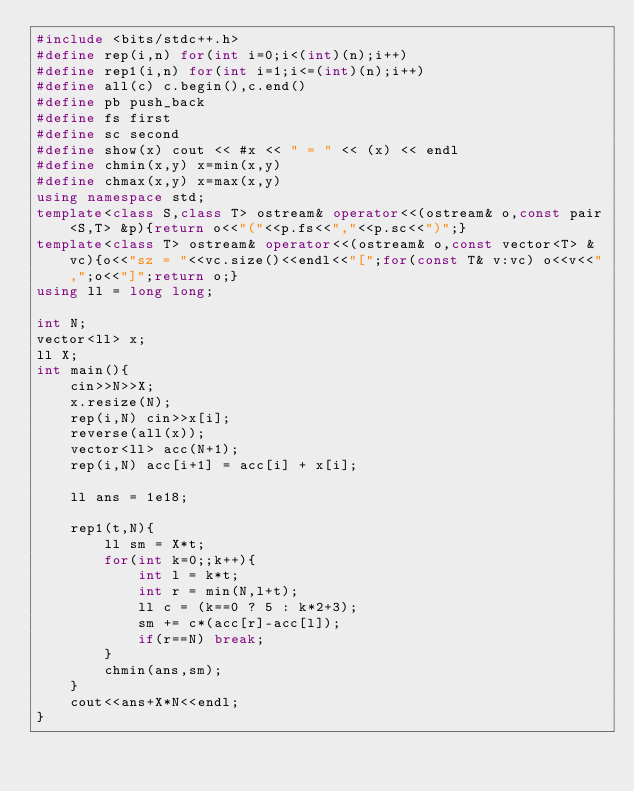<code> <loc_0><loc_0><loc_500><loc_500><_C++_>#include <bits/stdc++.h>
#define rep(i,n) for(int i=0;i<(int)(n);i++)
#define rep1(i,n) for(int i=1;i<=(int)(n);i++)
#define all(c) c.begin(),c.end()
#define pb push_back
#define fs first
#define sc second
#define show(x) cout << #x << " = " << (x) << endl
#define chmin(x,y) x=min(x,y)
#define chmax(x,y) x=max(x,y)
using namespace std;
template<class S,class T> ostream& operator<<(ostream& o,const pair<S,T> &p){return o<<"("<<p.fs<<","<<p.sc<<")";}
template<class T> ostream& operator<<(ostream& o,const vector<T> &vc){o<<"sz = "<<vc.size()<<endl<<"[";for(const T& v:vc) o<<v<<",";o<<"]";return o;}
using ll = long long;

int N;
vector<ll> x;
ll X;
int main(){
    cin>>N>>X;
    x.resize(N);
    rep(i,N) cin>>x[i];
    reverse(all(x));
    vector<ll> acc(N+1);
    rep(i,N) acc[i+1] = acc[i] + x[i];

    ll ans = 1e18;

    rep1(t,N){
        ll sm = X*t;
        for(int k=0;;k++){
            int l = k*t;
            int r = min(N,l+t);
            ll c = (k==0 ? 5 : k*2+3);
            sm += c*(acc[r]-acc[l]);
            if(r==N) break;
        }
        chmin(ans,sm);
    }
    cout<<ans+X*N<<endl;
}</code> 